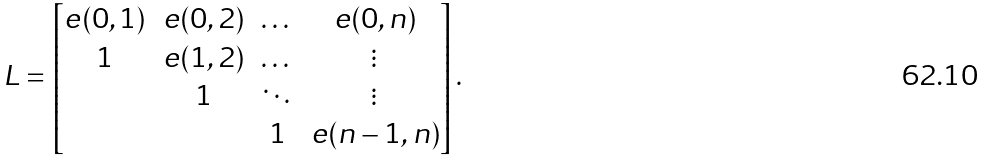<formula> <loc_0><loc_0><loc_500><loc_500>L = \begin{bmatrix} e ( 0 , 1 ) & e ( 0 , 2 ) & \dots & e ( 0 , n ) \\ 1 & e ( 1 , 2 ) & \dots & \vdots \\ & 1 & \ddots & \vdots \\ & & 1 & e ( n - 1 , n ) \end{bmatrix} .</formula> 